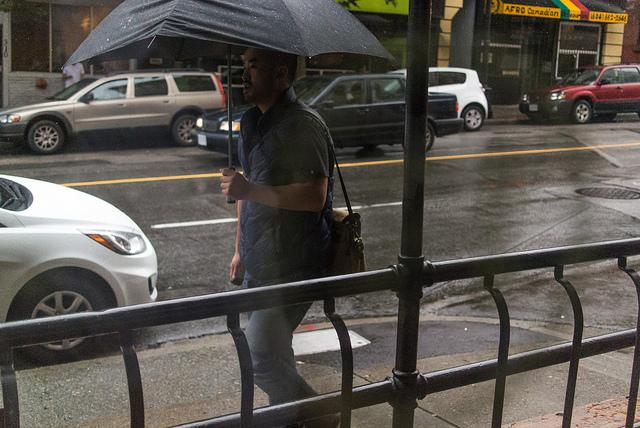From what does the man with the umbrella protect himself? rain 